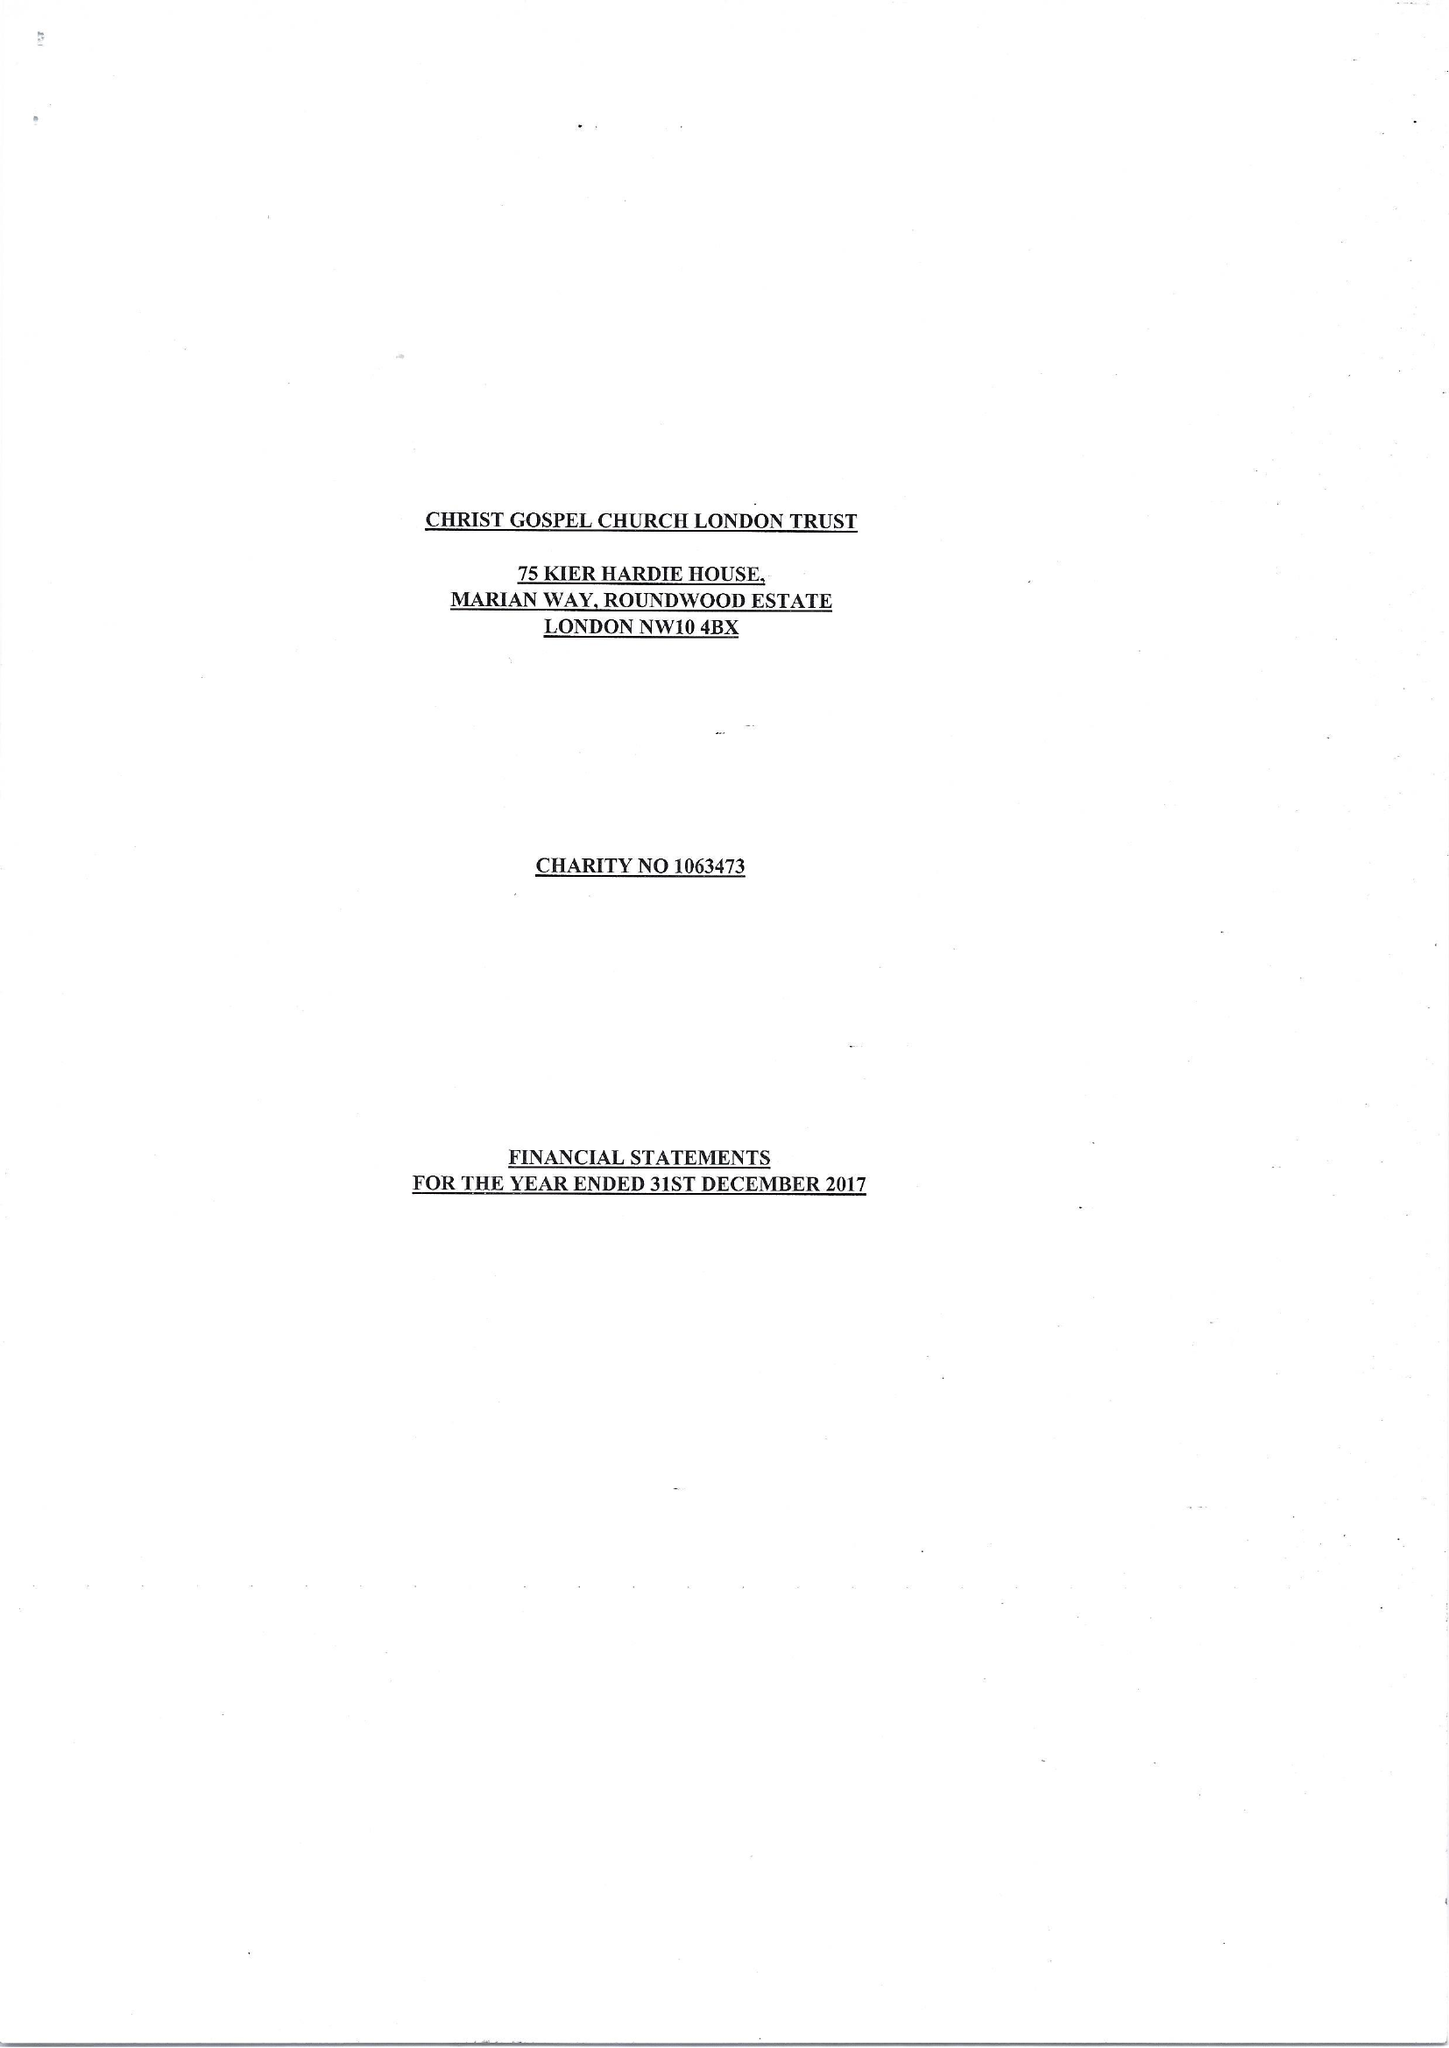What is the value for the spending_annually_in_british_pounds?
Answer the question using a single word or phrase. 18912.00 